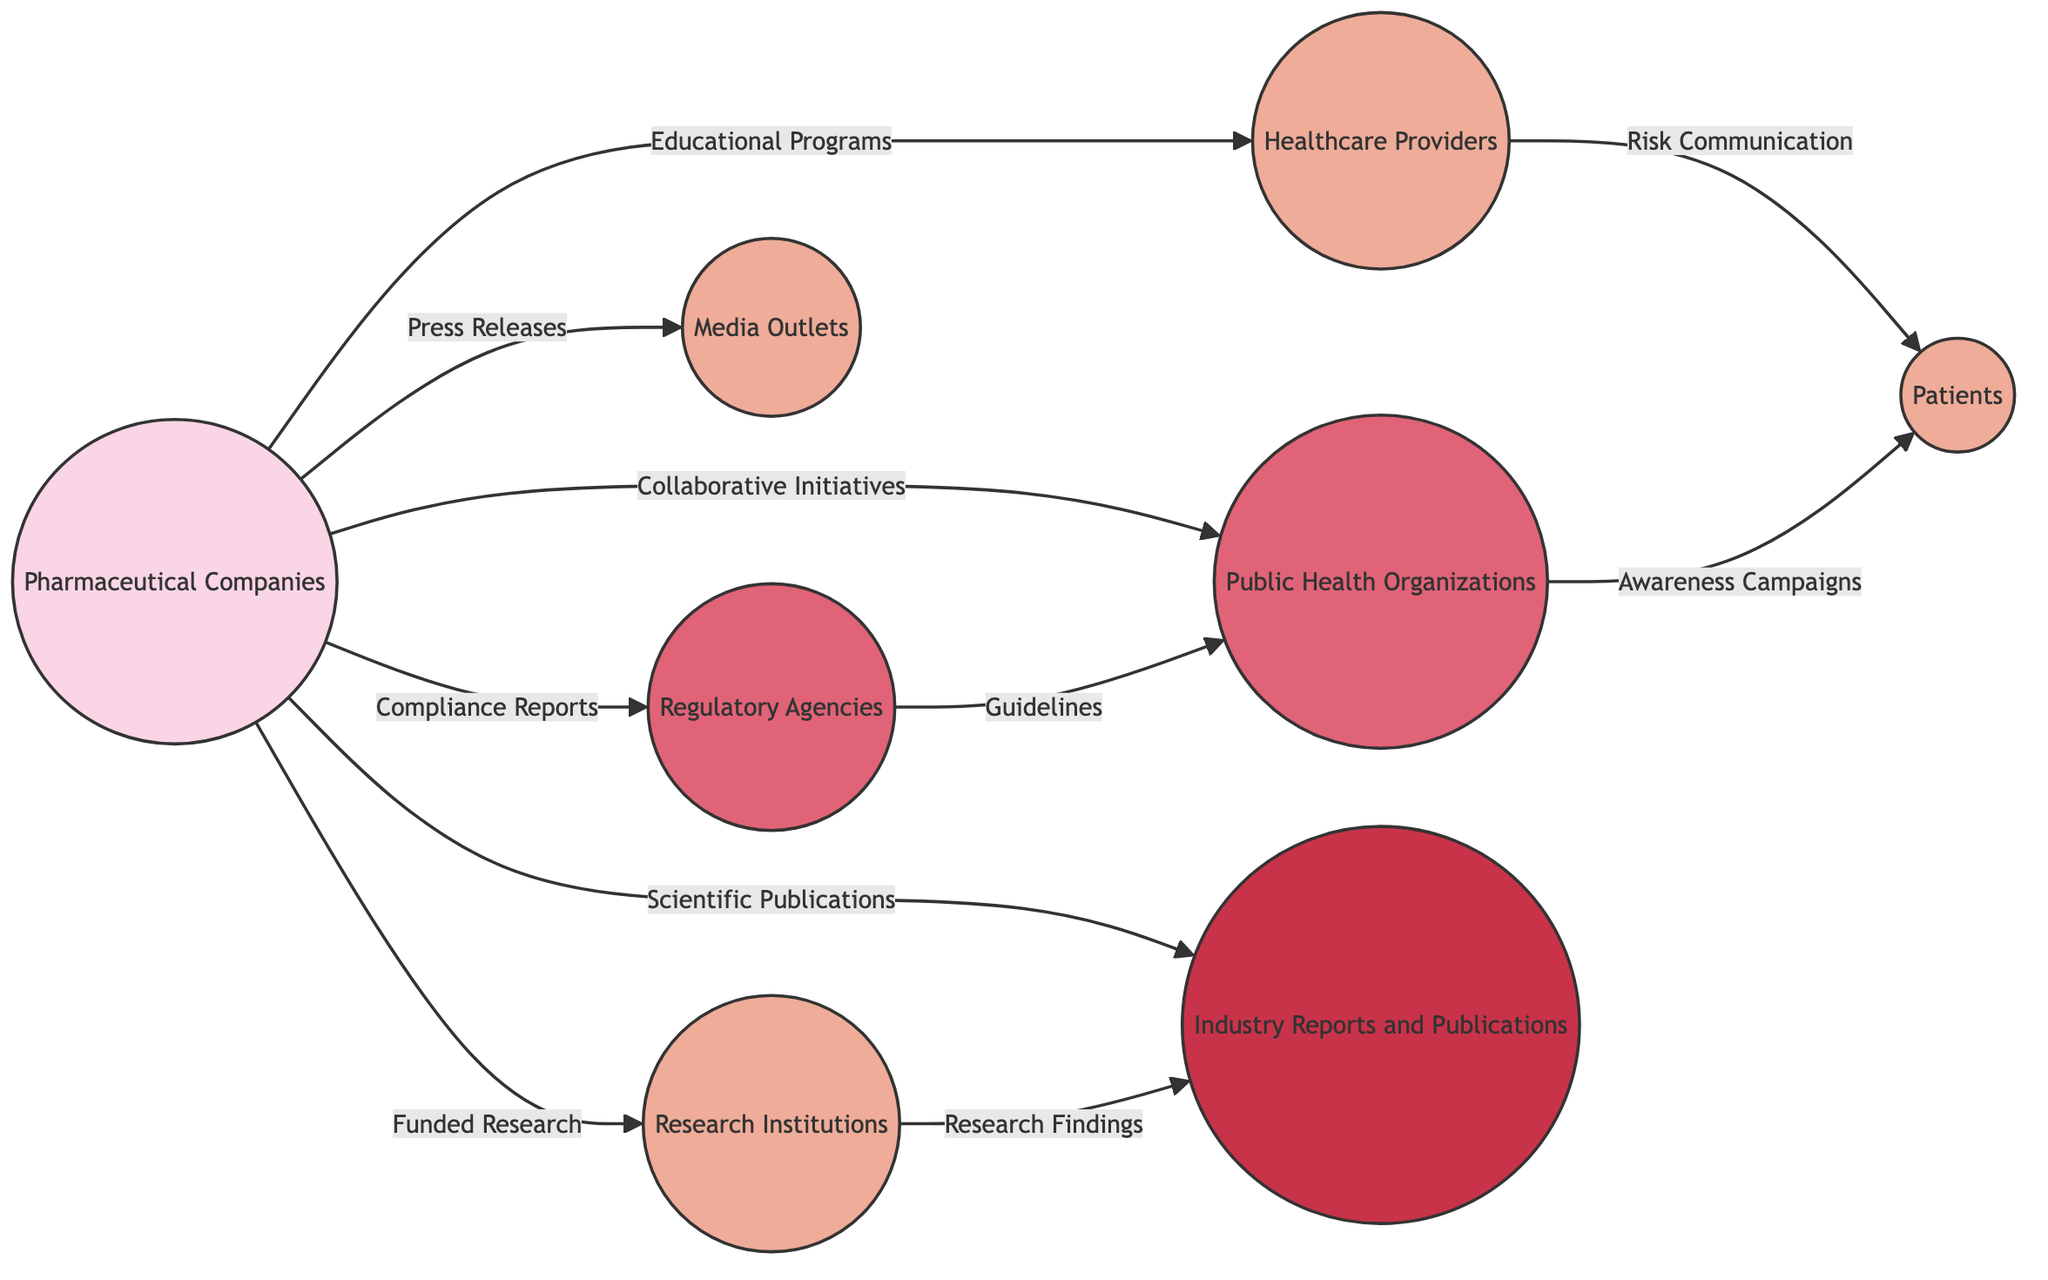What is the total number of nodes in the diagram? Count the unique entities represented in the diagram. The nodes listed are Pharmaceutical Companies, Healthcare Providers, Patients, Regulatory Agencies, Media Outlets, Public Health Organizations, Industry Reports and Publications, and Research Institutions, totaling 8 nodes.
Answer: 8 Which node communicates through press releases? Directly observe the connections labeled in the diagram; the edge from Pharmaceutical Companies to Media Outlets is labeled with "Press Releases," indicating this node communicates specifically through press releases.
Answer: Media Outlets How many different types of communication channels are identified in the diagram? Analyze the edges connecting nodes to determine the types of communication present. The edges represent various channels: Educational Programs, Compliance Reports, Risk Communication, Press Releases, Collaborative Initiatives, Scientific Publications, Funded Research, Research Findings, Guidelines, and Awareness Campaigns, totaling 10 distinct communication types.
Answer: 10 What is the relationship between Healthcare Providers and Patients? Refer to the diagram's edge between the two nodes labeled "Risk Communication." This label establishes that Healthcare Providers provide information regarding risks directly to Patients.
Answer: Risk Communication Which node collaborates with Public Health Organizations? Looking at the edges, the communication labeled "Collaborative Initiatives" from Pharmaceutical Companies points to Public Health Organizations, indicating that collaboration occurs between these two entities.
Answer: Pharmaceutical Companies What communication channel leads from Regulatory Agencies to Public Health Organizations? Identify the edge connecting these two nodes; it is labeled "Guidelines," indicating that this type of communication, which provides standards or protocols, flows from Regulatory Agencies to Public Health Organizations.
Answer: Guidelines Which node receives Research Findings from Research Institutions? Examine the directed edge leading from Research Institutions to Industry Reports and Publications; the connection is labeled "Research Findings," showing that this information flows toward Industry Reports and Publications.
Answer: Industry Reports and Publications How many edges are there in the diagram? Count the connections (edges) present in the diagram that link the nodes. Each edge represents a communication channel, and a count of these reveals that there are 10 edges in total.
Answer: 10 